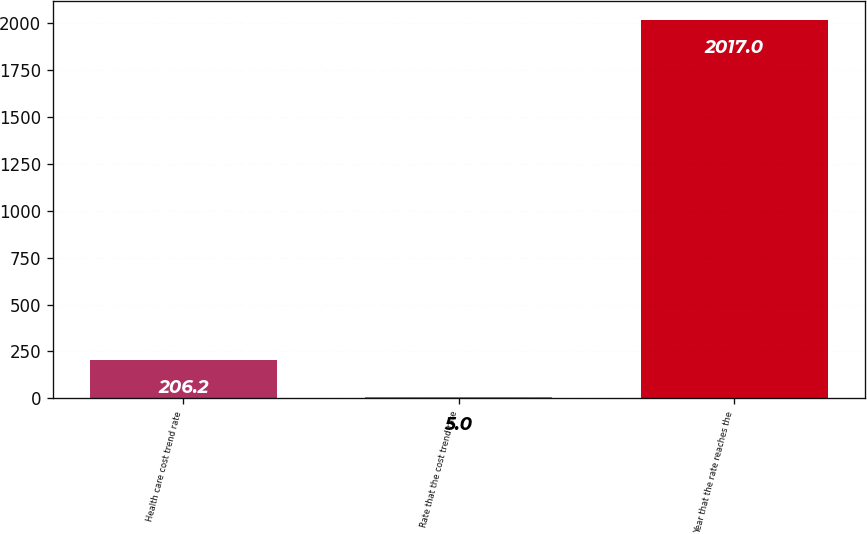<chart> <loc_0><loc_0><loc_500><loc_500><bar_chart><fcel>Health care cost trend rate<fcel>Rate that the cost trend rate<fcel>Year that the rate reaches the<nl><fcel>206.2<fcel>5<fcel>2017<nl></chart> 